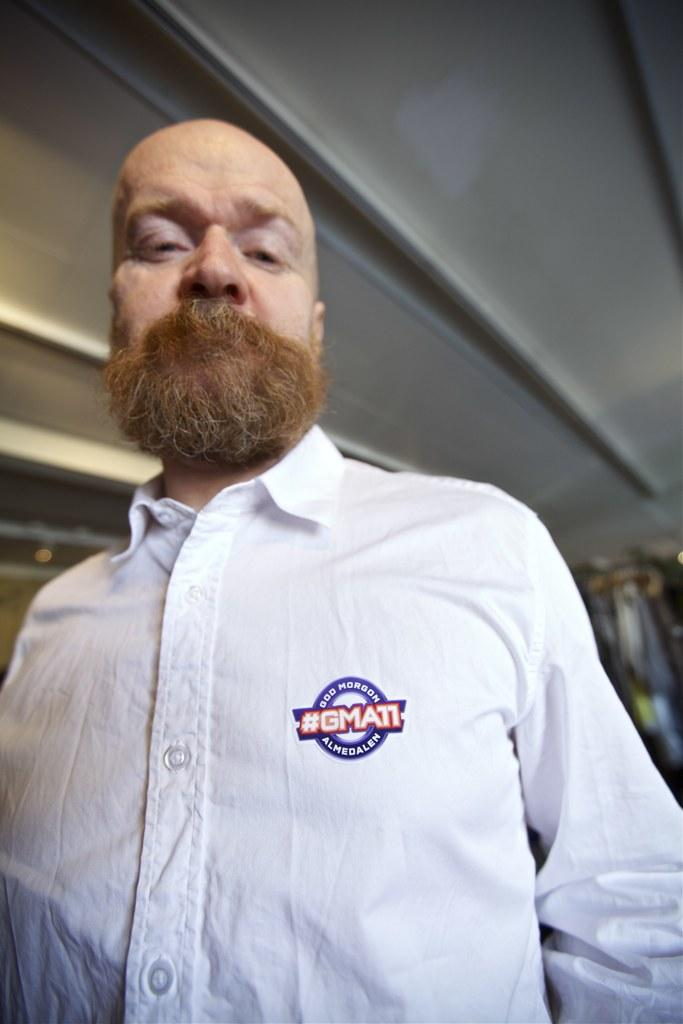What is the main subject of the image? There is a person in the image. What type of structure is visible in the image? There is a roof visible in the image. Can you describe the background of the image? The background of the image is blurred. What type of beef is being served by the lawyer in the image? There is no lawyer or beef present in the image. How does the person in the image stop the car? There is no car or indication of stopping in the image. 